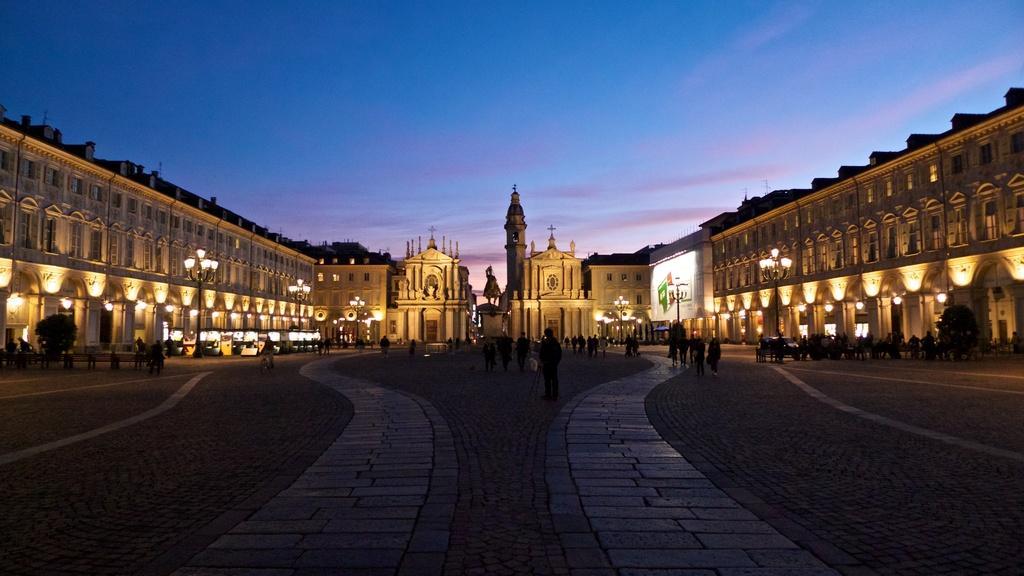Can you describe this image briefly? In this image we can see buildings, lights. There are people on the road. At the top of the image there is sky. In the center of the image there is a statue. 